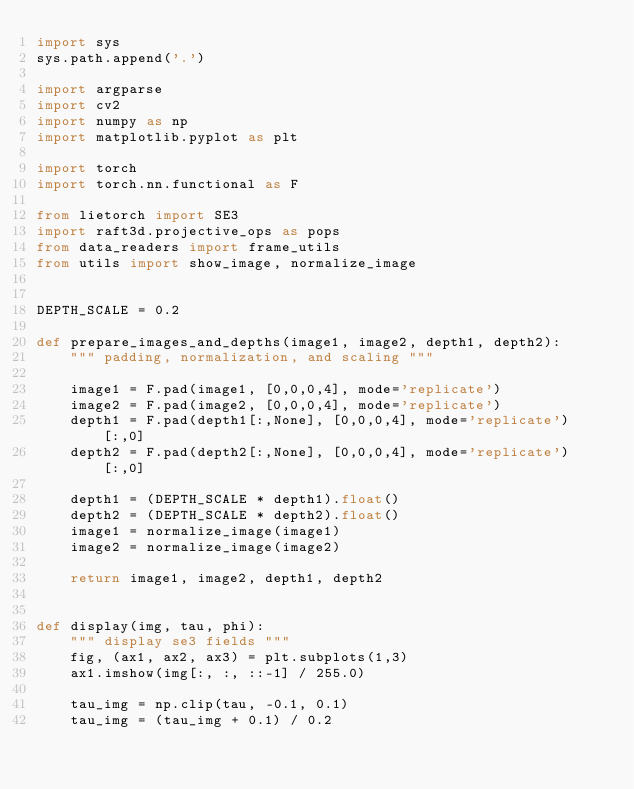<code> <loc_0><loc_0><loc_500><loc_500><_Python_>import sys
sys.path.append('.')

import argparse
import cv2
import numpy as np
import matplotlib.pyplot as plt

import torch
import torch.nn.functional as F

from lietorch import SE3
import raft3d.projective_ops as pops
from data_readers import frame_utils
from utils import show_image, normalize_image


DEPTH_SCALE = 0.2

def prepare_images_and_depths(image1, image2, depth1, depth2):
    """ padding, normalization, and scaling """

    image1 = F.pad(image1, [0,0,0,4], mode='replicate')
    image2 = F.pad(image2, [0,0,0,4], mode='replicate')
    depth1 = F.pad(depth1[:,None], [0,0,0,4], mode='replicate')[:,0]
    depth2 = F.pad(depth2[:,None], [0,0,0,4], mode='replicate')[:,0]

    depth1 = (DEPTH_SCALE * depth1).float()
    depth2 = (DEPTH_SCALE * depth2).float()
    image1 = normalize_image(image1)
    image2 = normalize_image(image2)

    return image1, image2, depth1, depth2


def display(img, tau, phi):
    """ display se3 fields """
    fig, (ax1, ax2, ax3) = plt.subplots(1,3)
    ax1.imshow(img[:, :, ::-1] / 255.0)

    tau_img = np.clip(tau, -0.1, 0.1)
    tau_img = (tau_img + 0.1) / 0.2
</code> 